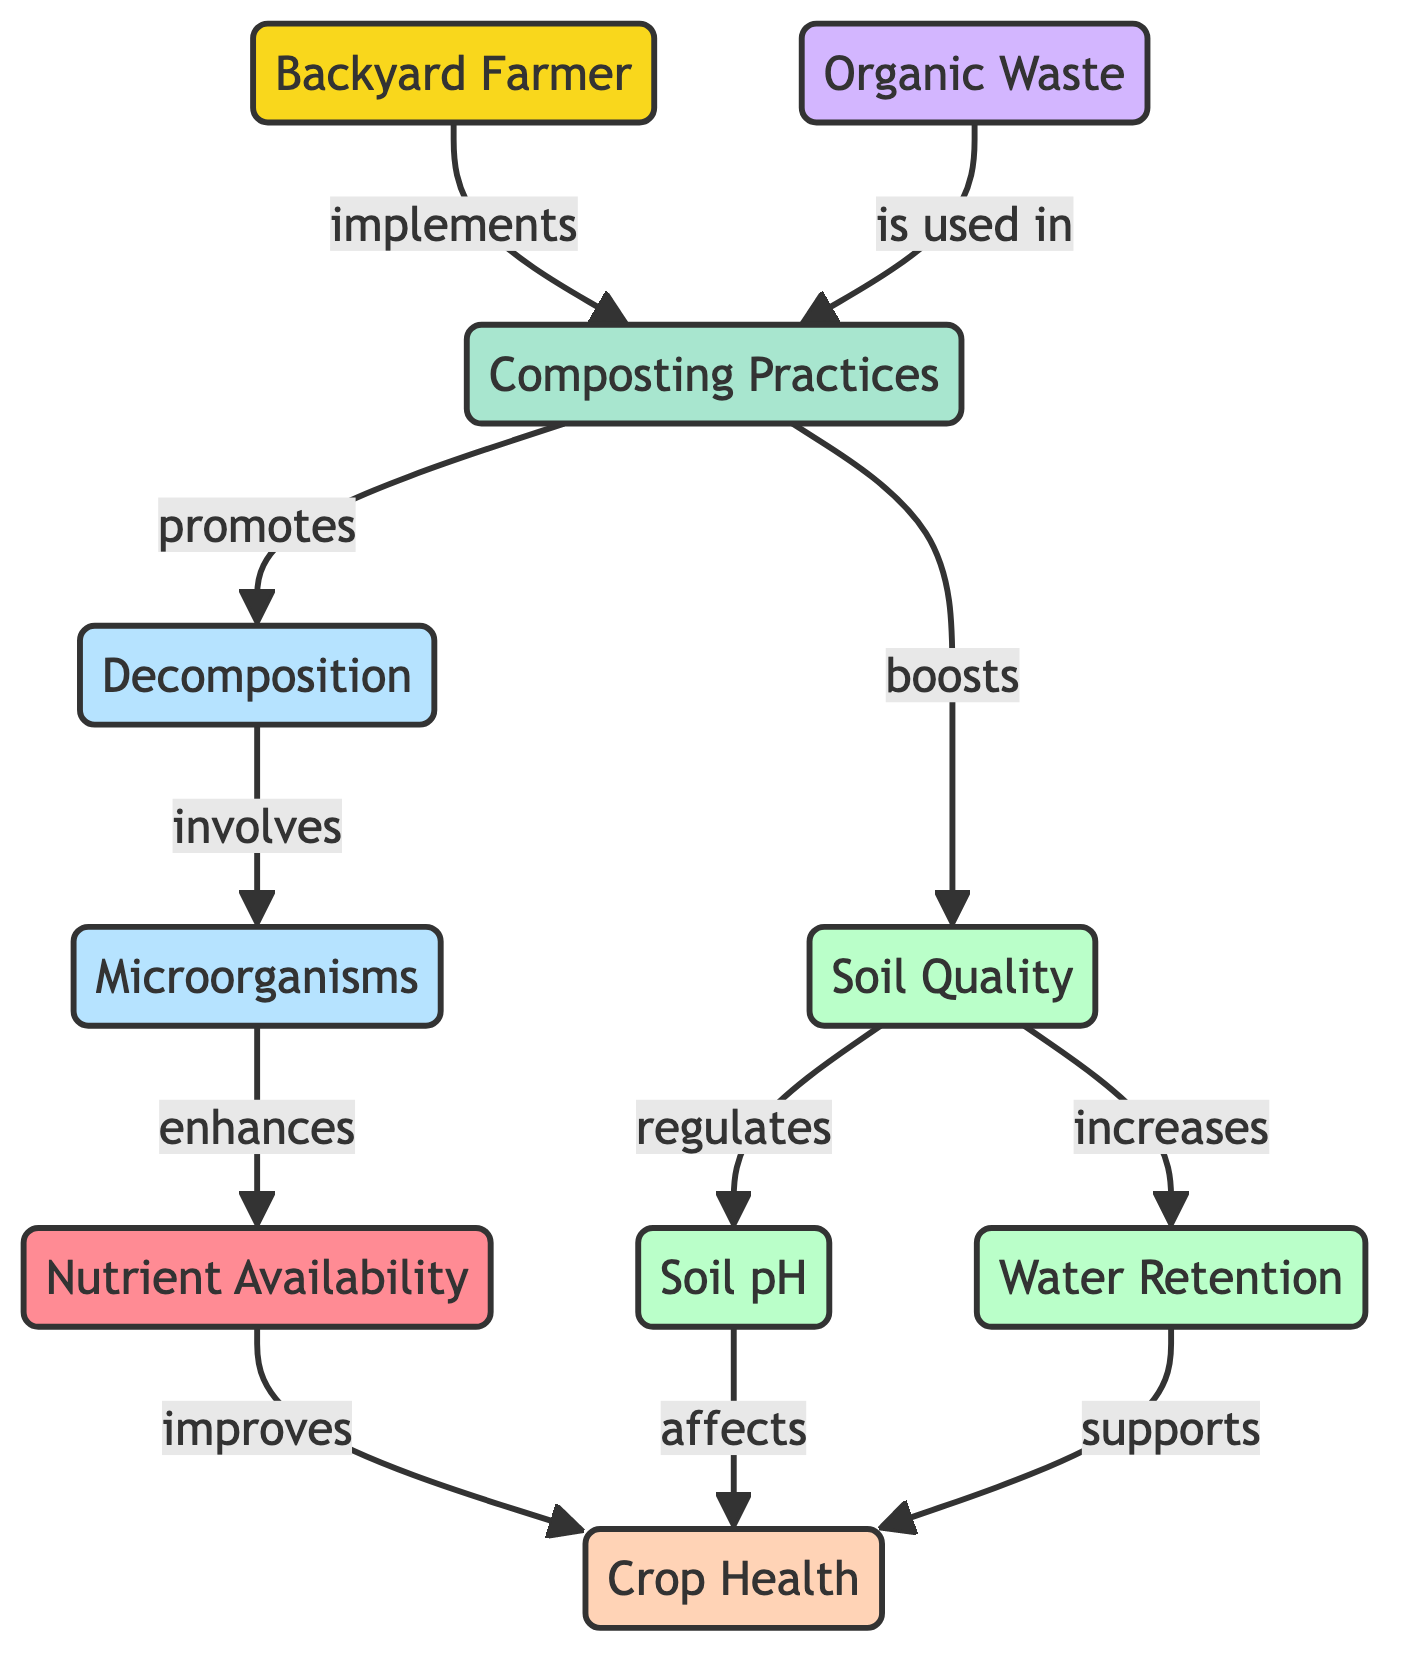What node does the Backyard Farmer implement? The Backyard Farmer node is directly connected to the Composting Practices node with the label "implements," which indicates that this is the action taken by the Backyard Farmer.
Answer: Composting Practices How many nodes are in the diagram? Counting all the unique nodes listed, there are ten nodes depicted in the diagram.
Answer: 10 What relationship does Composting Practices have with Decomposition? The Composting Practices node has a direct edge to the Decomposition node with the label "promotes," indicating that Composting Practices leads to or encourages Decomposition.
Answer: promotes Which node enhances Nutrient Availability? The Microorganisms node connects to the Nutrient Availability node with the label "enhances," meaning that Microorganisms increase or contribute positively to Nutrient Availability.
Answer: Microorganisms How is Soil Quality affected by Composting Practices? The Composting Practices node has a direct edge to Soil Quality labeled "boosts," which shows that Composting Practices have a positive effect on Soil Quality.
Answer: boosts What supports Crop Health according to the diagram? The diagram shows that both Water Retention and Soil pH have direct connections to the Crop Health node labeled "supports" and "affects," respectively, meaning both contribute to the health of crops.
Answer: Water Retention, Soil pH What is the effect of Soil Quality on Water Retention? The Soil Quality node is connected to the Water Retention node with the label "increases," showing that better Soil Quality leads to improved Water Retention.
Answer: increases What is the first action taken by the Backyard Farmer in the diagram? The first action illustrated in the diagram is the connection from the Backyard Farmer to Composting Practices, labeled "implements," indicating this is where the process begins.
Answer: implements How does Soil pH influence Crop Health? Soil pH has a direct relationship with Crop Health through the edge labeled "affects," demonstrating that the pH level of the soil can impact the health of crops significantly.
Answer: affects 